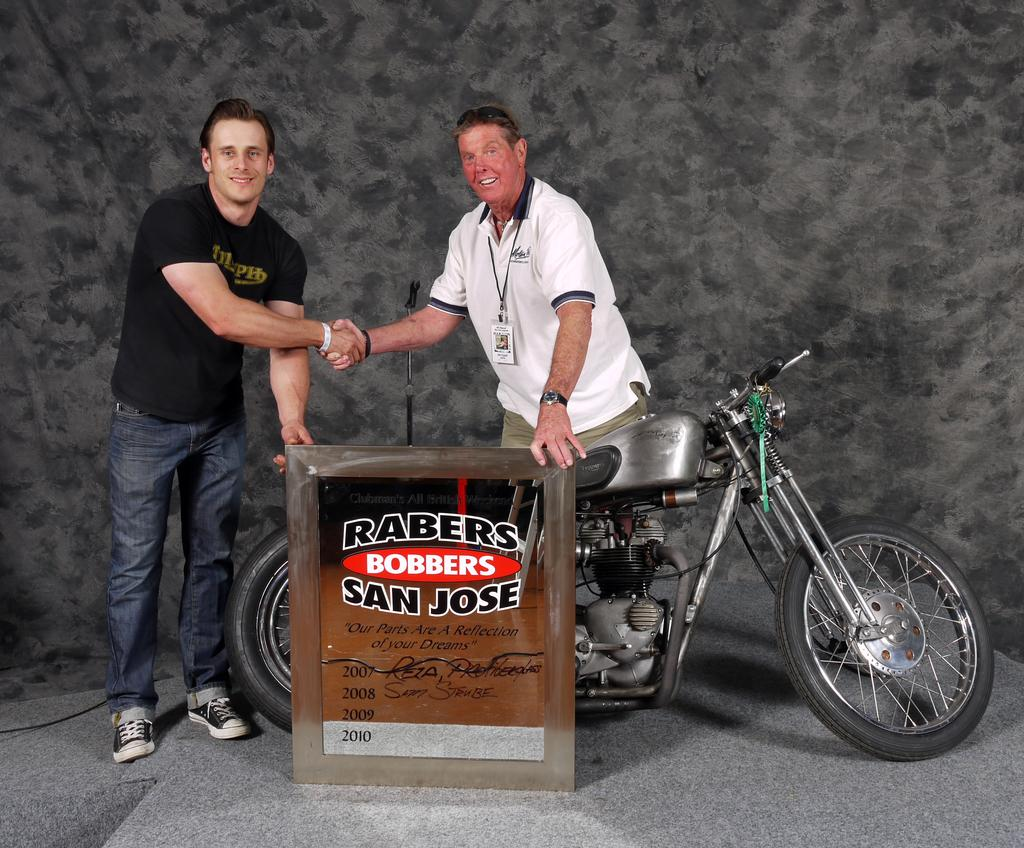How many people are in the image? There are two persons in the image. What are the two persons doing? The two persons are shaking hands. What is one of the persons holding? One of the persons is holding a board. What is between the person and the board? There is a bike between the person and the board. What can be seen in the background of the image? There is a wall in the background of the image. How many cats are sitting on the bike in the image? There are no cats present in the image. What type of quince is being used as a prop in the image? There is no quince present in the image. 